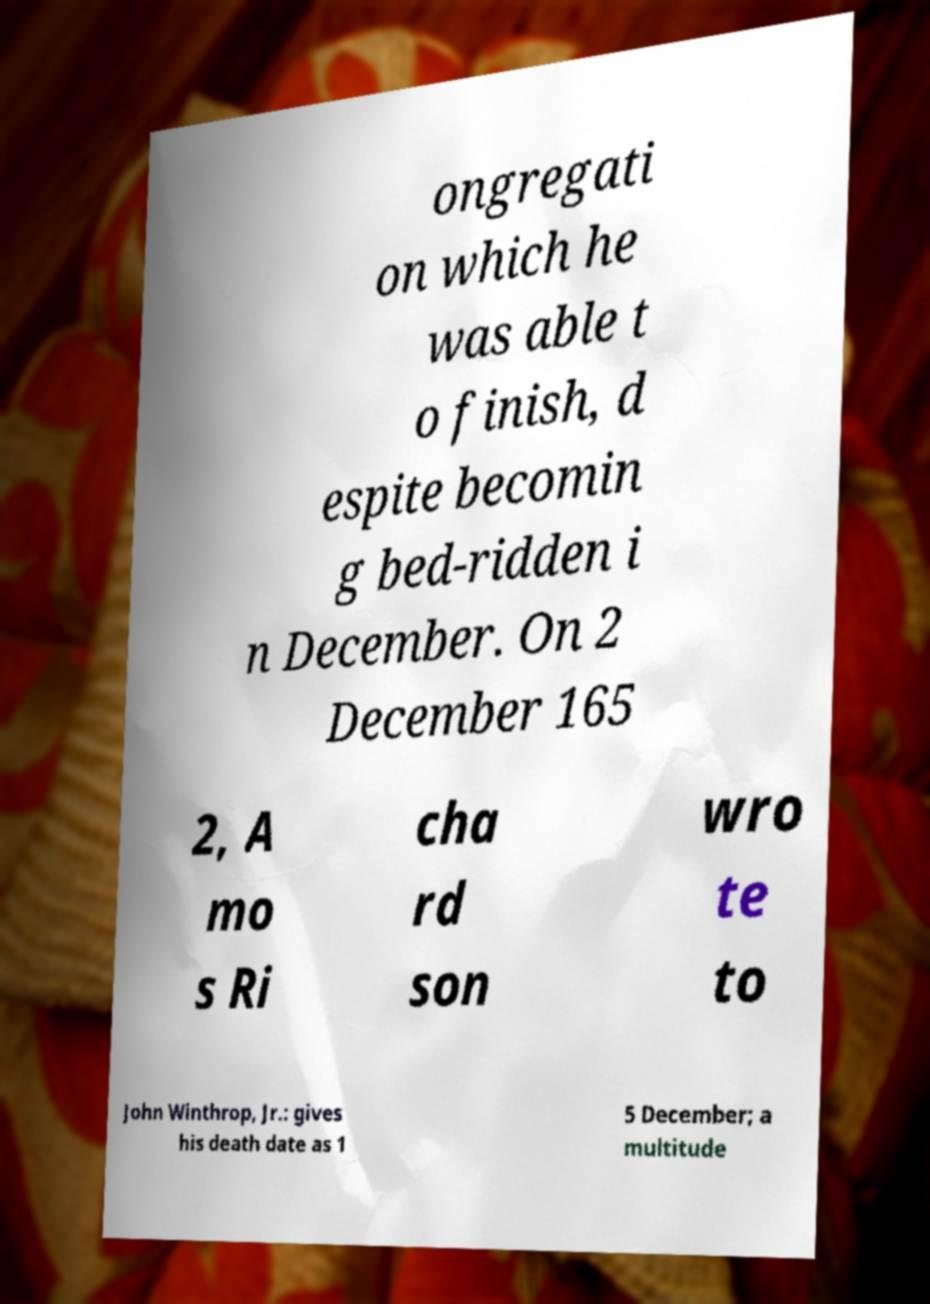What messages or text are displayed in this image? I need them in a readable, typed format. ongregati on which he was able t o finish, d espite becomin g bed-ridden i n December. On 2 December 165 2, A mo s Ri cha rd son wro te to John Winthrop, Jr.: gives his death date as 1 5 December; a multitude 